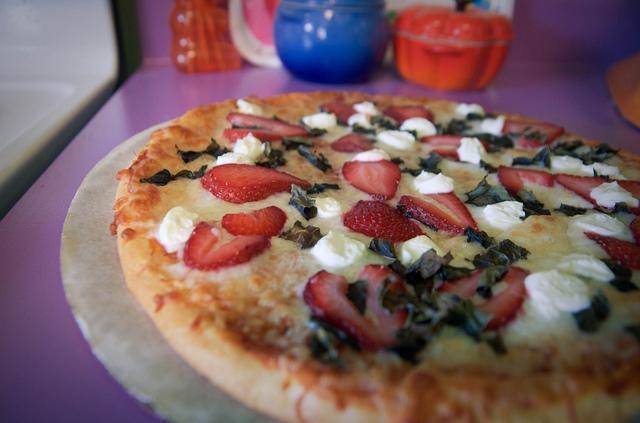How many women in brown hats are there?
Give a very brief answer. 0. 